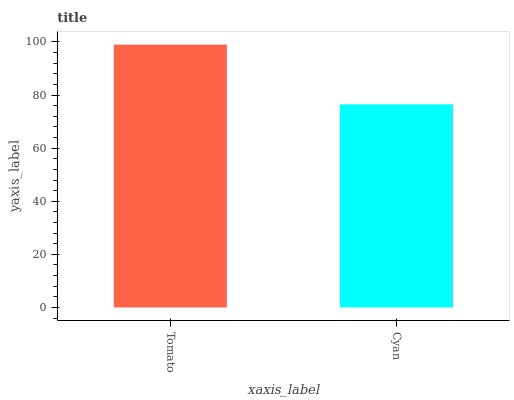Is Cyan the minimum?
Answer yes or no. Yes. Is Tomato the maximum?
Answer yes or no. Yes. Is Cyan the maximum?
Answer yes or no. No. Is Tomato greater than Cyan?
Answer yes or no. Yes. Is Cyan less than Tomato?
Answer yes or no. Yes. Is Cyan greater than Tomato?
Answer yes or no. No. Is Tomato less than Cyan?
Answer yes or no. No. Is Tomato the high median?
Answer yes or no. Yes. Is Cyan the low median?
Answer yes or no. Yes. Is Cyan the high median?
Answer yes or no. No. Is Tomato the low median?
Answer yes or no. No. 